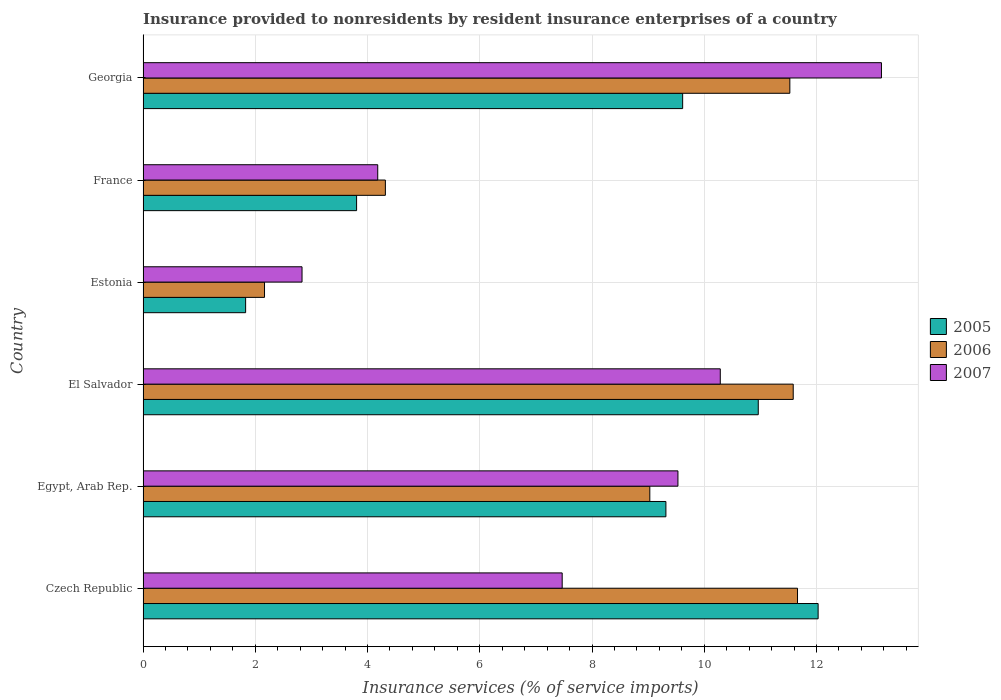How many different coloured bars are there?
Make the answer very short. 3. How many groups of bars are there?
Provide a short and direct response. 6. Are the number of bars per tick equal to the number of legend labels?
Your response must be concise. Yes. Are the number of bars on each tick of the Y-axis equal?
Provide a succinct answer. Yes. What is the label of the 3rd group of bars from the top?
Ensure brevity in your answer.  Estonia. What is the insurance provided to nonresidents in 2006 in Egypt, Arab Rep.?
Give a very brief answer. 9.03. Across all countries, what is the maximum insurance provided to nonresidents in 2006?
Ensure brevity in your answer.  11.66. Across all countries, what is the minimum insurance provided to nonresidents in 2007?
Your response must be concise. 2.83. In which country was the insurance provided to nonresidents in 2005 maximum?
Offer a very short reply. Czech Republic. In which country was the insurance provided to nonresidents in 2006 minimum?
Provide a succinct answer. Estonia. What is the total insurance provided to nonresidents in 2007 in the graph?
Offer a very short reply. 47.46. What is the difference between the insurance provided to nonresidents in 2005 in El Salvador and that in France?
Ensure brevity in your answer.  7.16. What is the difference between the insurance provided to nonresidents in 2007 in Egypt, Arab Rep. and the insurance provided to nonresidents in 2005 in Georgia?
Your answer should be very brief. -0.08. What is the average insurance provided to nonresidents in 2007 per country?
Your answer should be compact. 7.91. What is the difference between the insurance provided to nonresidents in 2006 and insurance provided to nonresidents in 2005 in Egypt, Arab Rep.?
Give a very brief answer. -0.29. What is the ratio of the insurance provided to nonresidents in 2007 in Czech Republic to that in France?
Give a very brief answer. 1.79. Is the insurance provided to nonresidents in 2007 in France less than that in Georgia?
Offer a terse response. Yes. What is the difference between the highest and the second highest insurance provided to nonresidents in 2005?
Provide a succinct answer. 1.07. What is the difference between the highest and the lowest insurance provided to nonresidents in 2005?
Ensure brevity in your answer.  10.2. What does the 3rd bar from the top in France represents?
Offer a very short reply. 2005. What does the 2nd bar from the bottom in France represents?
Give a very brief answer. 2006. How many bars are there?
Provide a short and direct response. 18. Are all the bars in the graph horizontal?
Offer a very short reply. Yes. Does the graph contain grids?
Ensure brevity in your answer.  Yes. Where does the legend appear in the graph?
Keep it short and to the point. Center right. What is the title of the graph?
Ensure brevity in your answer.  Insurance provided to nonresidents by resident insurance enterprises of a country. What is the label or title of the X-axis?
Provide a short and direct response. Insurance services (% of service imports). What is the label or title of the Y-axis?
Provide a short and direct response. Country. What is the Insurance services (% of service imports) in 2005 in Czech Republic?
Keep it short and to the point. 12.03. What is the Insurance services (% of service imports) in 2006 in Czech Republic?
Your response must be concise. 11.66. What is the Insurance services (% of service imports) in 2007 in Czech Republic?
Keep it short and to the point. 7.47. What is the Insurance services (% of service imports) of 2005 in Egypt, Arab Rep.?
Provide a succinct answer. 9.32. What is the Insurance services (% of service imports) of 2006 in Egypt, Arab Rep.?
Provide a short and direct response. 9.03. What is the Insurance services (% of service imports) in 2007 in Egypt, Arab Rep.?
Ensure brevity in your answer.  9.53. What is the Insurance services (% of service imports) in 2005 in El Salvador?
Keep it short and to the point. 10.96. What is the Insurance services (% of service imports) of 2006 in El Salvador?
Offer a terse response. 11.59. What is the Insurance services (% of service imports) in 2007 in El Salvador?
Provide a succinct answer. 10.29. What is the Insurance services (% of service imports) of 2005 in Estonia?
Offer a terse response. 1.83. What is the Insurance services (% of service imports) of 2006 in Estonia?
Keep it short and to the point. 2.16. What is the Insurance services (% of service imports) in 2007 in Estonia?
Offer a very short reply. 2.83. What is the Insurance services (% of service imports) in 2005 in France?
Offer a terse response. 3.81. What is the Insurance services (% of service imports) in 2006 in France?
Ensure brevity in your answer.  4.32. What is the Insurance services (% of service imports) of 2007 in France?
Keep it short and to the point. 4.18. What is the Insurance services (% of service imports) of 2005 in Georgia?
Keep it short and to the point. 9.62. What is the Insurance services (% of service imports) of 2006 in Georgia?
Your answer should be compact. 11.53. What is the Insurance services (% of service imports) of 2007 in Georgia?
Ensure brevity in your answer.  13.16. Across all countries, what is the maximum Insurance services (% of service imports) of 2005?
Offer a very short reply. 12.03. Across all countries, what is the maximum Insurance services (% of service imports) of 2006?
Give a very brief answer. 11.66. Across all countries, what is the maximum Insurance services (% of service imports) in 2007?
Your response must be concise. 13.16. Across all countries, what is the minimum Insurance services (% of service imports) of 2005?
Offer a very short reply. 1.83. Across all countries, what is the minimum Insurance services (% of service imports) in 2006?
Offer a terse response. 2.16. Across all countries, what is the minimum Insurance services (% of service imports) of 2007?
Your answer should be very brief. 2.83. What is the total Insurance services (% of service imports) in 2005 in the graph?
Ensure brevity in your answer.  47.56. What is the total Insurance services (% of service imports) in 2006 in the graph?
Keep it short and to the point. 50.28. What is the total Insurance services (% of service imports) of 2007 in the graph?
Your response must be concise. 47.46. What is the difference between the Insurance services (% of service imports) in 2005 in Czech Republic and that in Egypt, Arab Rep.?
Your answer should be very brief. 2.71. What is the difference between the Insurance services (% of service imports) of 2006 in Czech Republic and that in Egypt, Arab Rep.?
Keep it short and to the point. 2.63. What is the difference between the Insurance services (% of service imports) of 2007 in Czech Republic and that in Egypt, Arab Rep.?
Ensure brevity in your answer.  -2.06. What is the difference between the Insurance services (% of service imports) of 2005 in Czech Republic and that in El Salvador?
Your answer should be compact. 1.07. What is the difference between the Insurance services (% of service imports) of 2006 in Czech Republic and that in El Salvador?
Offer a very short reply. 0.08. What is the difference between the Insurance services (% of service imports) of 2007 in Czech Republic and that in El Salvador?
Give a very brief answer. -2.82. What is the difference between the Insurance services (% of service imports) of 2005 in Czech Republic and that in Estonia?
Your answer should be compact. 10.2. What is the difference between the Insurance services (% of service imports) in 2006 in Czech Republic and that in Estonia?
Provide a succinct answer. 9.5. What is the difference between the Insurance services (% of service imports) of 2007 in Czech Republic and that in Estonia?
Your answer should be compact. 4.64. What is the difference between the Insurance services (% of service imports) of 2005 in Czech Republic and that in France?
Offer a terse response. 8.22. What is the difference between the Insurance services (% of service imports) of 2006 in Czech Republic and that in France?
Keep it short and to the point. 7.34. What is the difference between the Insurance services (% of service imports) of 2007 in Czech Republic and that in France?
Offer a terse response. 3.29. What is the difference between the Insurance services (% of service imports) of 2005 in Czech Republic and that in Georgia?
Your answer should be very brief. 2.41. What is the difference between the Insurance services (% of service imports) in 2006 in Czech Republic and that in Georgia?
Your answer should be very brief. 0.14. What is the difference between the Insurance services (% of service imports) in 2007 in Czech Republic and that in Georgia?
Give a very brief answer. -5.69. What is the difference between the Insurance services (% of service imports) in 2005 in Egypt, Arab Rep. and that in El Salvador?
Make the answer very short. -1.65. What is the difference between the Insurance services (% of service imports) in 2006 in Egypt, Arab Rep. and that in El Salvador?
Keep it short and to the point. -2.56. What is the difference between the Insurance services (% of service imports) in 2007 in Egypt, Arab Rep. and that in El Salvador?
Provide a succinct answer. -0.75. What is the difference between the Insurance services (% of service imports) in 2005 in Egypt, Arab Rep. and that in Estonia?
Your response must be concise. 7.49. What is the difference between the Insurance services (% of service imports) of 2006 in Egypt, Arab Rep. and that in Estonia?
Provide a succinct answer. 6.87. What is the difference between the Insurance services (% of service imports) in 2007 in Egypt, Arab Rep. and that in Estonia?
Your answer should be very brief. 6.7. What is the difference between the Insurance services (% of service imports) in 2005 in Egypt, Arab Rep. and that in France?
Ensure brevity in your answer.  5.51. What is the difference between the Insurance services (% of service imports) of 2006 in Egypt, Arab Rep. and that in France?
Your answer should be very brief. 4.71. What is the difference between the Insurance services (% of service imports) of 2007 in Egypt, Arab Rep. and that in France?
Keep it short and to the point. 5.35. What is the difference between the Insurance services (% of service imports) in 2005 in Egypt, Arab Rep. and that in Georgia?
Give a very brief answer. -0.3. What is the difference between the Insurance services (% of service imports) of 2006 in Egypt, Arab Rep. and that in Georgia?
Provide a succinct answer. -2.5. What is the difference between the Insurance services (% of service imports) of 2007 in Egypt, Arab Rep. and that in Georgia?
Provide a succinct answer. -3.63. What is the difference between the Insurance services (% of service imports) of 2005 in El Salvador and that in Estonia?
Ensure brevity in your answer.  9.13. What is the difference between the Insurance services (% of service imports) in 2006 in El Salvador and that in Estonia?
Make the answer very short. 9.42. What is the difference between the Insurance services (% of service imports) in 2007 in El Salvador and that in Estonia?
Provide a short and direct response. 7.45. What is the difference between the Insurance services (% of service imports) in 2005 in El Salvador and that in France?
Offer a terse response. 7.16. What is the difference between the Insurance services (% of service imports) in 2006 in El Salvador and that in France?
Provide a short and direct response. 7.27. What is the difference between the Insurance services (% of service imports) in 2007 in El Salvador and that in France?
Your answer should be compact. 6.1. What is the difference between the Insurance services (% of service imports) in 2005 in El Salvador and that in Georgia?
Ensure brevity in your answer.  1.35. What is the difference between the Insurance services (% of service imports) of 2006 in El Salvador and that in Georgia?
Give a very brief answer. 0.06. What is the difference between the Insurance services (% of service imports) in 2007 in El Salvador and that in Georgia?
Make the answer very short. -2.87. What is the difference between the Insurance services (% of service imports) of 2005 in Estonia and that in France?
Make the answer very short. -1.98. What is the difference between the Insurance services (% of service imports) of 2006 in Estonia and that in France?
Your answer should be very brief. -2.15. What is the difference between the Insurance services (% of service imports) in 2007 in Estonia and that in France?
Your answer should be very brief. -1.35. What is the difference between the Insurance services (% of service imports) in 2005 in Estonia and that in Georgia?
Ensure brevity in your answer.  -7.79. What is the difference between the Insurance services (% of service imports) of 2006 in Estonia and that in Georgia?
Provide a succinct answer. -9.36. What is the difference between the Insurance services (% of service imports) of 2007 in Estonia and that in Georgia?
Give a very brief answer. -10.32. What is the difference between the Insurance services (% of service imports) in 2005 in France and that in Georgia?
Keep it short and to the point. -5.81. What is the difference between the Insurance services (% of service imports) of 2006 in France and that in Georgia?
Ensure brevity in your answer.  -7.21. What is the difference between the Insurance services (% of service imports) of 2007 in France and that in Georgia?
Your response must be concise. -8.98. What is the difference between the Insurance services (% of service imports) in 2005 in Czech Republic and the Insurance services (% of service imports) in 2006 in Egypt, Arab Rep.?
Provide a succinct answer. 3. What is the difference between the Insurance services (% of service imports) in 2005 in Czech Republic and the Insurance services (% of service imports) in 2007 in Egypt, Arab Rep.?
Give a very brief answer. 2.5. What is the difference between the Insurance services (% of service imports) in 2006 in Czech Republic and the Insurance services (% of service imports) in 2007 in Egypt, Arab Rep.?
Offer a very short reply. 2.13. What is the difference between the Insurance services (% of service imports) in 2005 in Czech Republic and the Insurance services (% of service imports) in 2006 in El Salvador?
Your answer should be very brief. 0.44. What is the difference between the Insurance services (% of service imports) in 2005 in Czech Republic and the Insurance services (% of service imports) in 2007 in El Salvador?
Offer a very short reply. 1.74. What is the difference between the Insurance services (% of service imports) of 2006 in Czech Republic and the Insurance services (% of service imports) of 2007 in El Salvador?
Your answer should be very brief. 1.38. What is the difference between the Insurance services (% of service imports) in 2005 in Czech Republic and the Insurance services (% of service imports) in 2006 in Estonia?
Keep it short and to the point. 9.87. What is the difference between the Insurance services (% of service imports) of 2005 in Czech Republic and the Insurance services (% of service imports) of 2007 in Estonia?
Provide a succinct answer. 9.2. What is the difference between the Insurance services (% of service imports) in 2006 in Czech Republic and the Insurance services (% of service imports) in 2007 in Estonia?
Your answer should be compact. 8.83. What is the difference between the Insurance services (% of service imports) of 2005 in Czech Republic and the Insurance services (% of service imports) of 2006 in France?
Give a very brief answer. 7.71. What is the difference between the Insurance services (% of service imports) in 2005 in Czech Republic and the Insurance services (% of service imports) in 2007 in France?
Make the answer very short. 7.85. What is the difference between the Insurance services (% of service imports) in 2006 in Czech Republic and the Insurance services (% of service imports) in 2007 in France?
Your answer should be very brief. 7.48. What is the difference between the Insurance services (% of service imports) in 2005 in Czech Republic and the Insurance services (% of service imports) in 2006 in Georgia?
Give a very brief answer. 0.5. What is the difference between the Insurance services (% of service imports) in 2005 in Czech Republic and the Insurance services (% of service imports) in 2007 in Georgia?
Provide a succinct answer. -1.13. What is the difference between the Insurance services (% of service imports) of 2006 in Czech Republic and the Insurance services (% of service imports) of 2007 in Georgia?
Your response must be concise. -1.5. What is the difference between the Insurance services (% of service imports) in 2005 in Egypt, Arab Rep. and the Insurance services (% of service imports) in 2006 in El Salvador?
Offer a terse response. -2.27. What is the difference between the Insurance services (% of service imports) in 2005 in Egypt, Arab Rep. and the Insurance services (% of service imports) in 2007 in El Salvador?
Offer a terse response. -0.97. What is the difference between the Insurance services (% of service imports) of 2006 in Egypt, Arab Rep. and the Insurance services (% of service imports) of 2007 in El Salvador?
Provide a succinct answer. -1.26. What is the difference between the Insurance services (% of service imports) in 2005 in Egypt, Arab Rep. and the Insurance services (% of service imports) in 2006 in Estonia?
Provide a succinct answer. 7.15. What is the difference between the Insurance services (% of service imports) in 2005 in Egypt, Arab Rep. and the Insurance services (% of service imports) in 2007 in Estonia?
Provide a succinct answer. 6.48. What is the difference between the Insurance services (% of service imports) of 2006 in Egypt, Arab Rep. and the Insurance services (% of service imports) of 2007 in Estonia?
Your answer should be compact. 6.2. What is the difference between the Insurance services (% of service imports) in 2005 in Egypt, Arab Rep. and the Insurance services (% of service imports) in 2006 in France?
Ensure brevity in your answer.  5. What is the difference between the Insurance services (% of service imports) of 2005 in Egypt, Arab Rep. and the Insurance services (% of service imports) of 2007 in France?
Your answer should be compact. 5.13. What is the difference between the Insurance services (% of service imports) of 2006 in Egypt, Arab Rep. and the Insurance services (% of service imports) of 2007 in France?
Provide a short and direct response. 4.85. What is the difference between the Insurance services (% of service imports) in 2005 in Egypt, Arab Rep. and the Insurance services (% of service imports) in 2006 in Georgia?
Your answer should be compact. -2.21. What is the difference between the Insurance services (% of service imports) of 2005 in Egypt, Arab Rep. and the Insurance services (% of service imports) of 2007 in Georgia?
Make the answer very short. -3.84. What is the difference between the Insurance services (% of service imports) in 2006 in Egypt, Arab Rep. and the Insurance services (% of service imports) in 2007 in Georgia?
Ensure brevity in your answer.  -4.13. What is the difference between the Insurance services (% of service imports) in 2005 in El Salvador and the Insurance services (% of service imports) in 2006 in Estonia?
Offer a terse response. 8.8. What is the difference between the Insurance services (% of service imports) of 2005 in El Salvador and the Insurance services (% of service imports) of 2007 in Estonia?
Provide a succinct answer. 8.13. What is the difference between the Insurance services (% of service imports) of 2006 in El Salvador and the Insurance services (% of service imports) of 2007 in Estonia?
Provide a short and direct response. 8.75. What is the difference between the Insurance services (% of service imports) in 2005 in El Salvador and the Insurance services (% of service imports) in 2006 in France?
Make the answer very short. 6.64. What is the difference between the Insurance services (% of service imports) in 2005 in El Salvador and the Insurance services (% of service imports) in 2007 in France?
Ensure brevity in your answer.  6.78. What is the difference between the Insurance services (% of service imports) of 2006 in El Salvador and the Insurance services (% of service imports) of 2007 in France?
Give a very brief answer. 7.4. What is the difference between the Insurance services (% of service imports) of 2005 in El Salvador and the Insurance services (% of service imports) of 2006 in Georgia?
Provide a short and direct response. -0.56. What is the difference between the Insurance services (% of service imports) of 2005 in El Salvador and the Insurance services (% of service imports) of 2007 in Georgia?
Your answer should be compact. -2.2. What is the difference between the Insurance services (% of service imports) in 2006 in El Salvador and the Insurance services (% of service imports) in 2007 in Georgia?
Your response must be concise. -1.57. What is the difference between the Insurance services (% of service imports) of 2005 in Estonia and the Insurance services (% of service imports) of 2006 in France?
Your answer should be very brief. -2.49. What is the difference between the Insurance services (% of service imports) in 2005 in Estonia and the Insurance services (% of service imports) in 2007 in France?
Offer a very short reply. -2.35. What is the difference between the Insurance services (% of service imports) of 2006 in Estonia and the Insurance services (% of service imports) of 2007 in France?
Offer a terse response. -2.02. What is the difference between the Insurance services (% of service imports) in 2005 in Estonia and the Insurance services (% of service imports) in 2006 in Georgia?
Ensure brevity in your answer.  -9.7. What is the difference between the Insurance services (% of service imports) in 2005 in Estonia and the Insurance services (% of service imports) in 2007 in Georgia?
Provide a short and direct response. -11.33. What is the difference between the Insurance services (% of service imports) of 2006 in Estonia and the Insurance services (% of service imports) of 2007 in Georgia?
Your answer should be very brief. -10.99. What is the difference between the Insurance services (% of service imports) of 2005 in France and the Insurance services (% of service imports) of 2006 in Georgia?
Your answer should be very brief. -7.72. What is the difference between the Insurance services (% of service imports) in 2005 in France and the Insurance services (% of service imports) in 2007 in Georgia?
Ensure brevity in your answer.  -9.35. What is the difference between the Insurance services (% of service imports) of 2006 in France and the Insurance services (% of service imports) of 2007 in Georgia?
Provide a short and direct response. -8.84. What is the average Insurance services (% of service imports) in 2005 per country?
Make the answer very short. 7.93. What is the average Insurance services (% of service imports) of 2006 per country?
Give a very brief answer. 8.38. What is the average Insurance services (% of service imports) in 2007 per country?
Make the answer very short. 7.91. What is the difference between the Insurance services (% of service imports) in 2005 and Insurance services (% of service imports) in 2006 in Czech Republic?
Keep it short and to the point. 0.37. What is the difference between the Insurance services (% of service imports) of 2005 and Insurance services (% of service imports) of 2007 in Czech Republic?
Your response must be concise. 4.56. What is the difference between the Insurance services (% of service imports) in 2006 and Insurance services (% of service imports) in 2007 in Czech Republic?
Your answer should be compact. 4.19. What is the difference between the Insurance services (% of service imports) of 2005 and Insurance services (% of service imports) of 2006 in Egypt, Arab Rep.?
Make the answer very short. 0.29. What is the difference between the Insurance services (% of service imports) in 2005 and Insurance services (% of service imports) in 2007 in Egypt, Arab Rep.?
Provide a succinct answer. -0.21. What is the difference between the Insurance services (% of service imports) of 2006 and Insurance services (% of service imports) of 2007 in Egypt, Arab Rep.?
Give a very brief answer. -0.5. What is the difference between the Insurance services (% of service imports) in 2005 and Insurance services (% of service imports) in 2006 in El Salvador?
Make the answer very short. -0.62. What is the difference between the Insurance services (% of service imports) in 2005 and Insurance services (% of service imports) in 2007 in El Salvador?
Your answer should be compact. 0.68. What is the difference between the Insurance services (% of service imports) of 2006 and Insurance services (% of service imports) of 2007 in El Salvador?
Make the answer very short. 1.3. What is the difference between the Insurance services (% of service imports) of 2005 and Insurance services (% of service imports) of 2006 in Estonia?
Your answer should be very brief. -0.34. What is the difference between the Insurance services (% of service imports) of 2005 and Insurance services (% of service imports) of 2007 in Estonia?
Your response must be concise. -1.01. What is the difference between the Insurance services (% of service imports) of 2006 and Insurance services (% of service imports) of 2007 in Estonia?
Give a very brief answer. -0.67. What is the difference between the Insurance services (% of service imports) in 2005 and Insurance services (% of service imports) in 2006 in France?
Give a very brief answer. -0.51. What is the difference between the Insurance services (% of service imports) in 2005 and Insurance services (% of service imports) in 2007 in France?
Keep it short and to the point. -0.38. What is the difference between the Insurance services (% of service imports) in 2006 and Insurance services (% of service imports) in 2007 in France?
Ensure brevity in your answer.  0.14. What is the difference between the Insurance services (% of service imports) of 2005 and Insurance services (% of service imports) of 2006 in Georgia?
Offer a very short reply. -1.91. What is the difference between the Insurance services (% of service imports) of 2005 and Insurance services (% of service imports) of 2007 in Georgia?
Your answer should be compact. -3.54. What is the difference between the Insurance services (% of service imports) of 2006 and Insurance services (% of service imports) of 2007 in Georgia?
Keep it short and to the point. -1.63. What is the ratio of the Insurance services (% of service imports) of 2005 in Czech Republic to that in Egypt, Arab Rep.?
Provide a short and direct response. 1.29. What is the ratio of the Insurance services (% of service imports) in 2006 in Czech Republic to that in Egypt, Arab Rep.?
Provide a succinct answer. 1.29. What is the ratio of the Insurance services (% of service imports) in 2007 in Czech Republic to that in Egypt, Arab Rep.?
Make the answer very short. 0.78. What is the ratio of the Insurance services (% of service imports) in 2005 in Czech Republic to that in El Salvador?
Your response must be concise. 1.1. What is the ratio of the Insurance services (% of service imports) of 2006 in Czech Republic to that in El Salvador?
Your response must be concise. 1.01. What is the ratio of the Insurance services (% of service imports) of 2007 in Czech Republic to that in El Salvador?
Your response must be concise. 0.73. What is the ratio of the Insurance services (% of service imports) of 2005 in Czech Republic to that in Estonia?
Make the answer very short. 6.58. What is the ratio of the Insurance services (% of service imports) in 2006 in Czech Republic to that in Estonia?
Ensure brevity in your answer.  5.39. What is the ratio of the Insurance services (% of service imports) of 2007 in Czech Republic to that in Estonia?
Provide a short and direct response. 2.64. What is the ratio of the Insurance services (% of service imports) in 2005 in Czech Republic to that in France?
Offer a very short reply. 3.16. What is the ratio of the Insurance services (% of service imports) of 2006 in Czech Republic to that in France?
Offer a very short reply. 2.7. What is the ratio of the Insurance services (% of service imports) in 2007 in Czech Republic to that in France?
Offer a terse response. 1.79. What is the ratio of the Insurance services (% of service imports) in 2005 in Czech Republic to that in Georgia?
Ensure brevity in your answer.  1.25. What is the ratio of the Insurance services (% of service imports) of 2006 in Czech Republic to that in Georgia?
Your response must be concise. 1.01. What is the ratio of the Insurance services (% of service imports) in 2007 in Czech Republic to that in Georgia?
Offer a terse response. 0.57. What is the ratio of the Insurance services (% of service imports) in 2005 in Egypt, Arab Rep. to that in El Salvador?
Your answer should be compact. 0.85. What is the ratio of the Insurance services (% of service imports) of 2006 in Egypt, Arab Rep. to that in El Salvador?
Give a very brief answer. 0.78. What is the ratio of the Insurance services (% of service imports) in 2007 in Egypt, Arab Rep. to that in El Salvador?
Provide a short and direct response. 0.93. What is the ratio of the Insurance services (% of service imports) in 2005 in Egypt, Arab Rep. to that in Estonia?
Ensure brevity in your answer.  5.1. What is the ratio of the Insurance services (% of service imports) of 2006 in Egypt, Arab Rep. to that in Estonia?
Offer a terse response. 4.17. What is the ratio of the Insurance services (% of service imports) of 2007 in Egypt, Arab Rep. to that in Estonia?
Provide a succinct answer. 3.36. What is the ratio of the Insurance services (% of service imports) in 2005 in Egypt, Arab Rep. to that in France?
Your answer should be very brief. 2.45. What is the ratio of the Insurance services (% of service imports) in 2006 in Egypt, Arab Rep. to that in France?
Make the answer very short. 2.09. What is the ratio of the Insurance services (% of service imports) in 2007 in Egypt, Arab Rep. to that in France?
Your response must be concise. 2.28. What is the ratio of the Insurance services (% of service imports) in 2006 in Egypt, Arab Rep. to that in Georgia?
Keep it short and to the point. 0.78. What is the ratio of the Insurance services (% of service imports) of 2007 in Egypt, Arab Rep. to that in Georgia?
Give a very brief answer. 0.72. What is the ratio of the Insurance services (% of service imports) in 2005 in El Salvador to that in Estonia?
Provide a short and direct response. 6. What is the ratio of the Insurance services (% of service imports) of 2006 in El Salvador to that in Estonia?
Provide a short and direct response. 5.35. What is the ratio of the Insurance services (% of service imports) in 2007 in El Salvador to that in Estonia?
Ensure brevity in your answer.  3.63. What is the ratio of the Insurance services (% of service imports) of 2005 in El Salvador to that in France?
Offer a very short reply. 2.88. What is the ratio of the Insurance services (% of service imports) of 2006 in El Salvador to that in France?
Keep it short and to the point. 2.68. What is the ratio of the Insurance services (% of service imports) of 2007 in El Salvador to that in France?
Provide a short and direct response. 2.46. What is the ratio of the Insurance services (% of service imports) of 2005 in El Salvador to that in Georgia?
Your response must be concise. 1.14. What is the ratio of the Insurance services (% of service imports) of 2006 in El Salvador to that in Georgia?
Your response must be concise. 1.01. What is the ratio of the Insurance services (% of service imports) in 2007 in El Salvador to that in Georgia?
Your response must be concise. 0.78. What is the ratio of the Insurance services (% of service imports) of 2005 in Estonia to that in France?
Make the answer very short. 0.48. What is the ratio of the Insurance services (% of service imports) in 2006 in Estonia to that in France?
Your answer should be compact. 0.5. What is the ratio of the Insurance services (% of service imports) in 2007 in Estonia to that in France?
Give a very brief answer. 0.68. What is the ratio of the Insurance services (% of service imports) in 2005 in Estonia to that in Georgia?
Your response must be concise. 0.19. What is the ratio of the Insurance services (% of service imports) in 2006 in Estonia to that in Georgia?
Provide a succinct answer. 0.19. What is the ratio of the Insurance services (% of service imports) in 2007 in Estonia to that in Georgia?
Offer a terse response. 0.22. What is the ratio of the Insurance services (% of service imports) in 2005 in France to that in Georgia?
Provide a short and direct response. 0.4. What is the ratio of the Insurance services (% of service imports) of 2006 in France to that in Georgia?
Your response must be concise. 0.37. What is the ratio of the Insurance services (% of service imports) of 2007 in France to that in Georgia?
Ensure brevity in your answer.  0.32. What is the difference between the highest and the second highest Insurance services (% of service imports) in 2005?
Your answer should be very brief. 1.07. What is the difference between the highest and the second highest Insurance services (% of service imports) of 2006?
Offer a very short reply. 0.08. What is the difference between the highest and the second highest Insurance services (% of service imports) of 2007?
Give a very brief answer. 2.87. What is the difference between the highest and the lowest Insurance services (% of service imports) in 2005?
Your answer should be very brief. 10.2. What is the difference between the highest and the lowest Insurance services (% of service imports) of 2006?
Your response must be concise. 9.5. What is the difference between the highest and the lowest Insurance services (% of service imports) in 2007?
Make the answer very short. 10.32. 